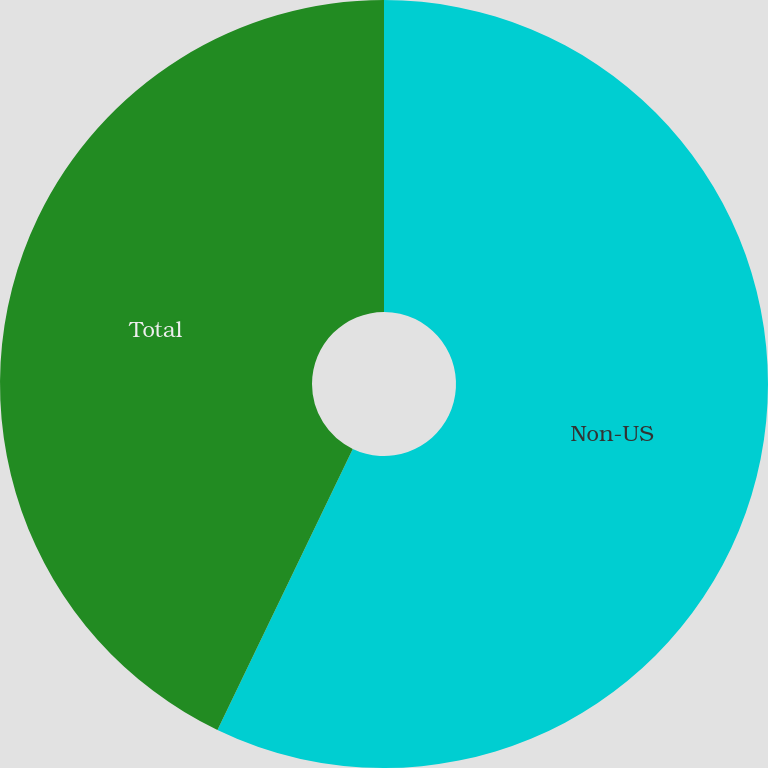<chart> <loc_0><loc_0><loc_500><loc_500><pie_chart><fcel>Non-US<fcel>Total<nl><fcel>57.14%<fcel>42.86%<nl></chart> 